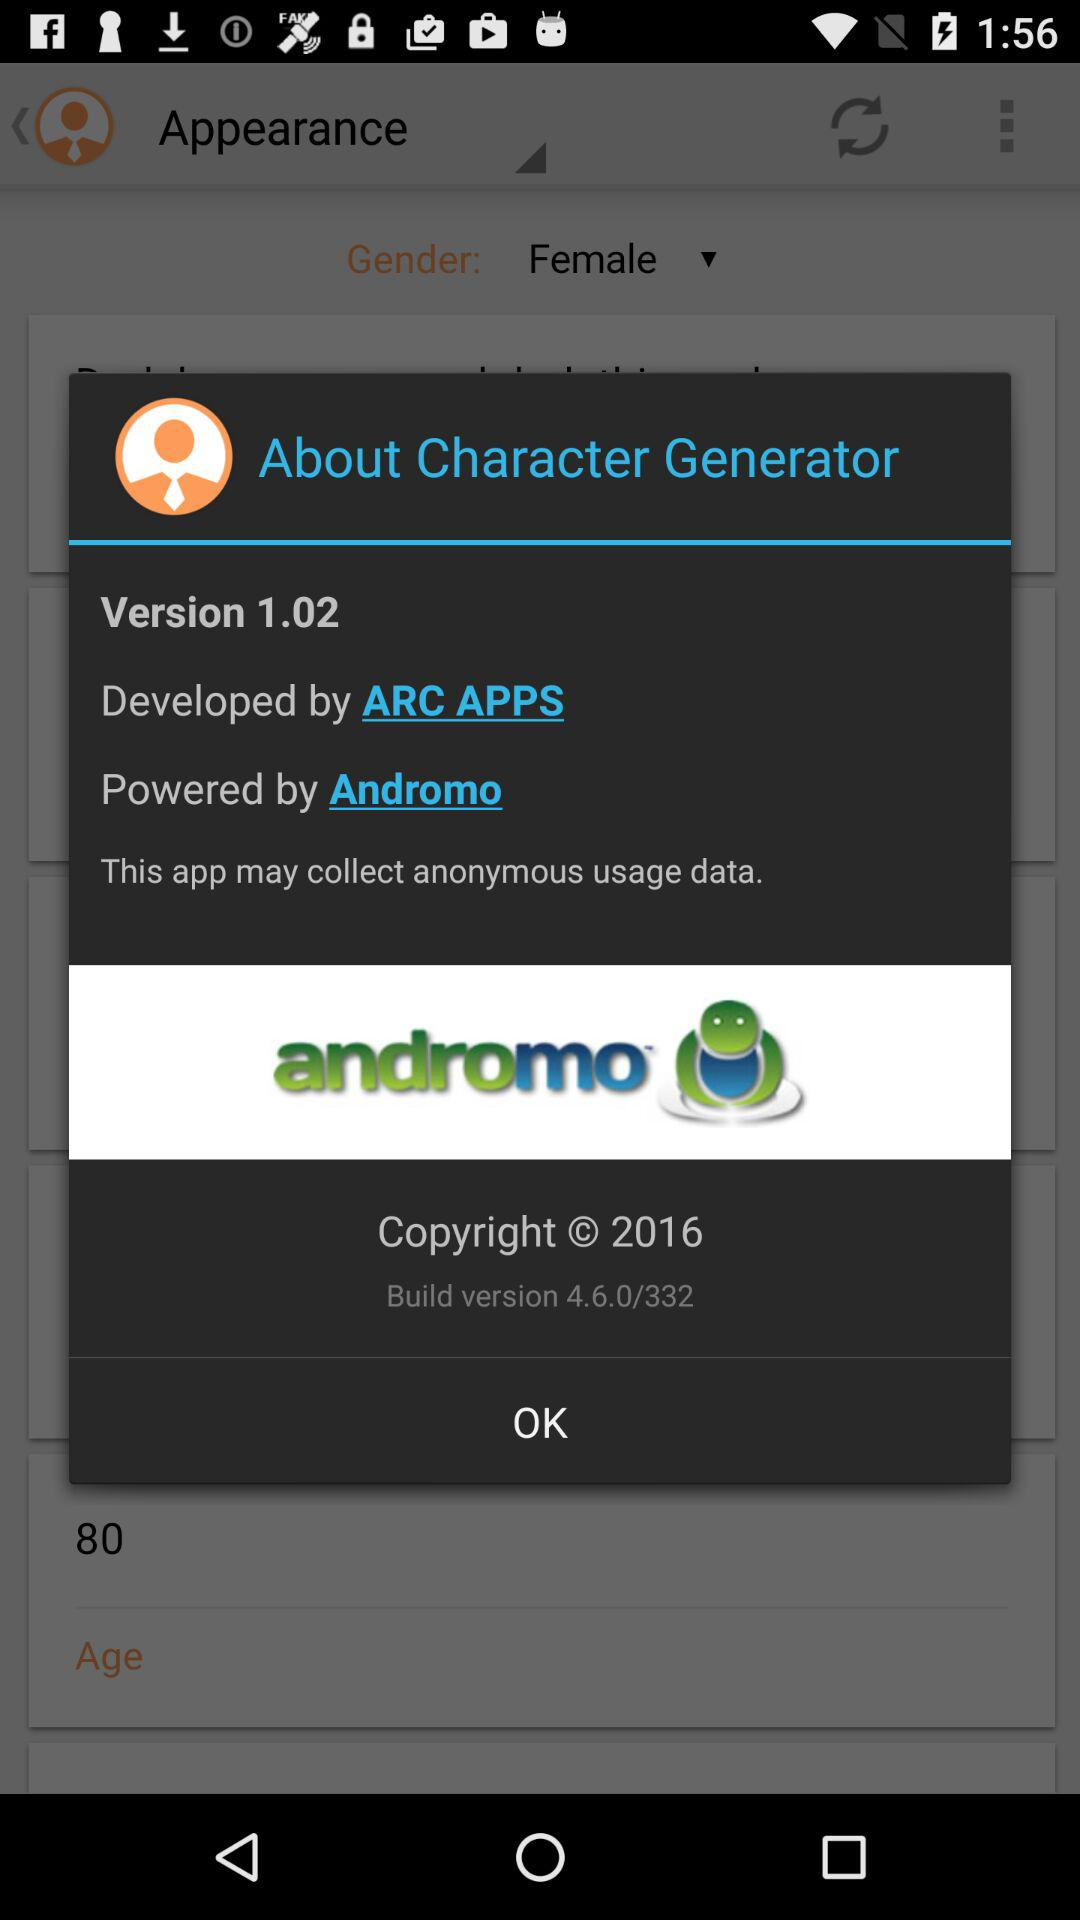What is the version of "Character Generator"? The version of "Character Generator" is 1.02. 